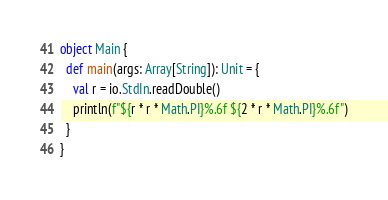<code> <loc_0><loc_0><loc_500><loc_500><_Scala_>object Main {
  def main(args: Array[String]): Unit = {
    val r = io.StdIn.readDouble()
    println(f"${r * r * Math.PI}%.6f ${2 * r * Math.PI}%.6f")
  }
}</code> 